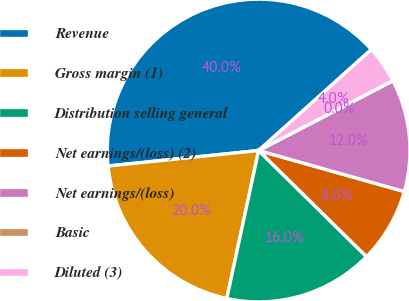Convert chart to OTSL. <chart><loc_0><loc_0><loc_500><loc_500><pie_chart><fcel>Revenue<fcel>Gross margin (1)<fcel>Distribution selling general<fcel>Net earnings/(loss) (2)<fcel>Net earnings/(loss)<fcel>Basic<fcel>Diluted (3)<nl><fcel>40.0%<fcel>20.0%<fcel>16.0%<fcel>8.0%<fcel>12.0%<fcel>0.0%<fcel>4.0%<nl></chart> 